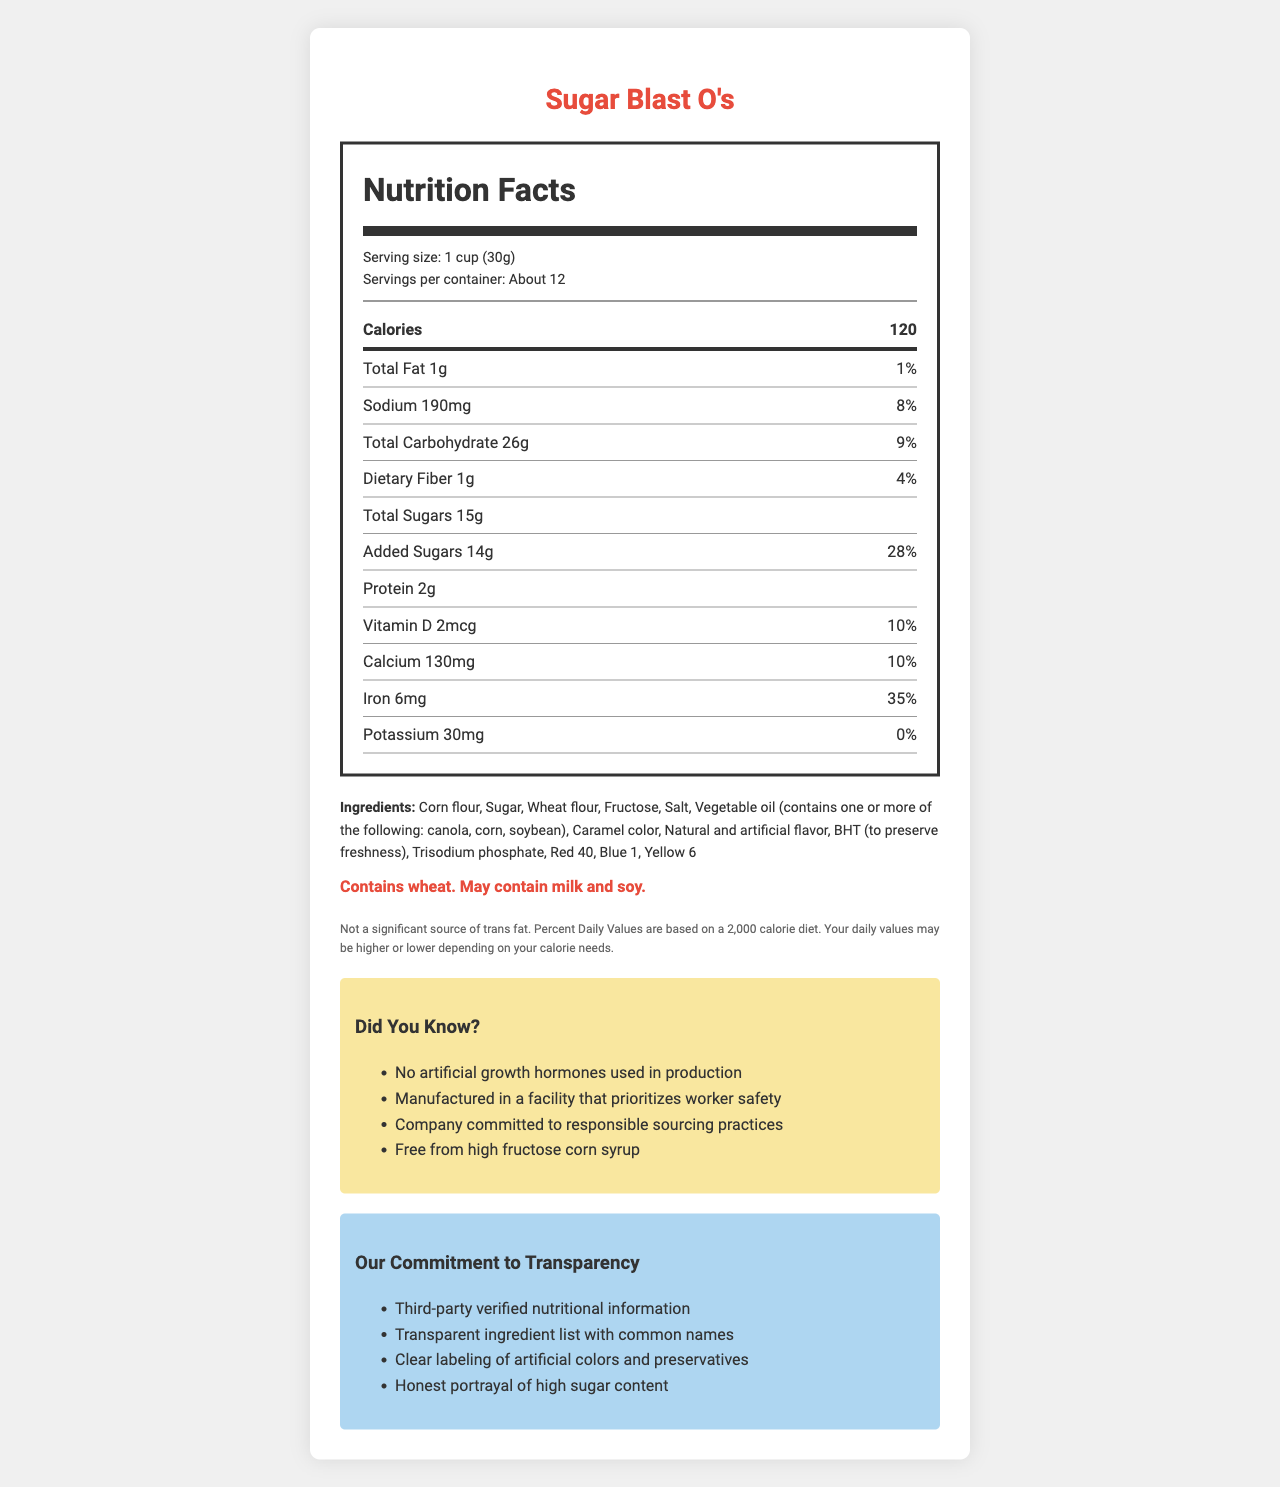what is the serving size of Sugar Blast O's? The serving size information is listed right at the top of the nutrition facts section.
Answer: 1 cup (30g) how many calories are in one serving? The number of calories per serving is prominently displayed in the major nutrient section.
Answer: 120 what percentage of daily value is the total carbohydrate content? The total carbohydrate amount is 26g, and the daily value percentage is given as 9%.
Answer: 9% how many grams of sugars are added sugars? The document specifies the total sugars amount as 15g, with 14g being the added sugars.
Answer: 14g what artificial ingredients are listed in the ingredients section? The ingredients section lists these specific artificial ingredients.
Answer: Caramel color, Natural and artificial flavor, BHT, Trisodium phosphate, Red 40, Blue 1, Yellow 6 which of these is not present in Sugar Blast O's? A. High fructose corn syrup B. Red 40 C. Canola oil The document specifically states the cereal is free from high fructose corn syrup, whereas Red 40 and canola oil are listed in the ingredients.
Answer: A what is the daily value percentage of iron? A. 10% B. 28% C. 35% D. 4% The daily value percentage for iron is given as 35%.
Answer: C is the product free from artificial growth hormones? The section targeted at the persona mentions the product has no artificial growth hormones used in production.
Answer: Yes summarize the main idea of the document. The document covers various aspects of the nutrition facts, ingredients, allergen info, and additional claims to provide an overall picture of the cereal’s contents and the manufacturer's commitments.
Answer: The document provides a detailed nutritional label for Sugar Blast O's cereal, highlighting its high sugar content and artificial ingredients, while also attempting to ensure consumer trust through transparent labeling and third-party verification. what is the exact amount of dietary fiber in one serving? The amount of dietary fiber per serving is listed as 1g in the nutrition facts.
Answer: 1g which ingredient listed is a preservative? BHT is mentioned in the ingredients as being used to preserve freshness.
Answer: BHT how many vitamins and minerals are listed with their daily value percentages? A. 3 B. 4 C. 5 The document lists Vitamin D, Calcium, Iron, and Potassium with their respective daily value percentages.
Answer: B does the product contain milk? The allergen info states the product "may contain milk," but it does not conclusively state whether it does.
Answer: Cannot be determined what company manufactures Sugar Blast O's? The manufacturer information is provided in the document, stating that Big Food Corp. makes the product.
Answer: Big Food Corp. 